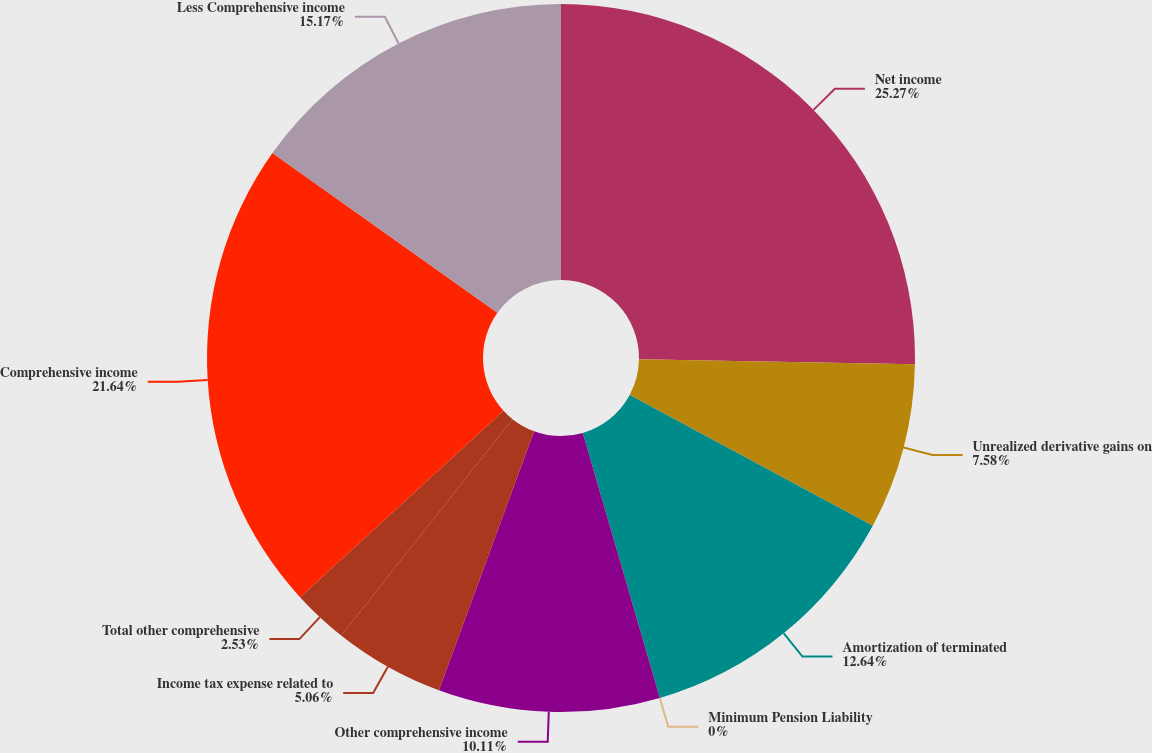Convert chart to OTSL. <chart><loc_0><loc_0><loc_500><loc_500><pie_chart><fcel>Net income<fcel>Unrealized derivative gains on<fcel>Amortization of terminated<fcel>Minimum Pension Liability<fcel>Other comprehensive income<fcel>Income tax expense related to<fcel>Total other comprehensive<fcel>Comprehensive income<fcel>Less Comprehensive income<nl><fcel>25.28%<fcel>7.58%<fcel>12.64%<fcel>0.0%<fcel>10.11%<fcel>5.06%<fcel>2.53%<fcel>21.64%<fcel>15.17%<nl></chart> 